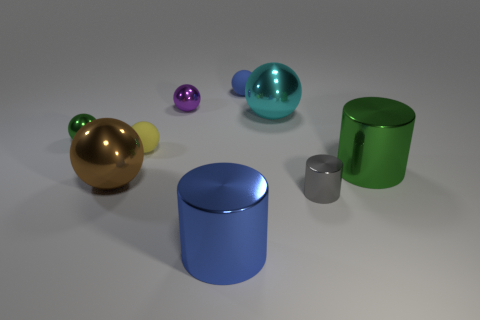Subtract all cyan metal balls. How many balls are left? 5 Subtract all green spheres. How many spheres are left? 5 Add 1 small objects. How many objects exist? 10 Subtract all blue balls. Subtract all red cubes. How many balls are left? 5 Subtract all cylinders. How many objects are left? 6 Add 5 purple things. How many purple things are left? 6 Add 2 tiny yellow spheres. How many tiny yellow spheres exist? 3 Subtract 1 purple balls. How many objects are left? 8 Subtract all brown metallic objects. Subtract all tiny things. How many objects are left? 3 